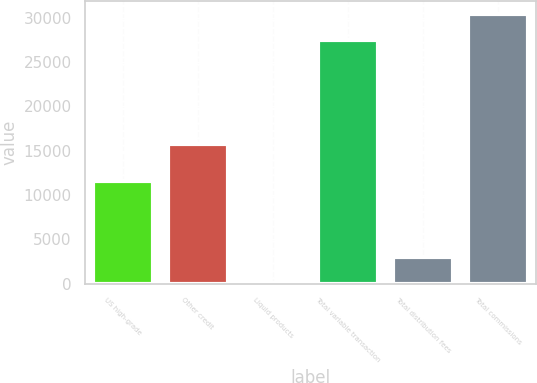<chart> <loc_0><loc_0><loc_500><loc_500><bar_chart><fcel>US high-grade<fcel>Other credit<fcel>Liquid products<fcel>Total variable transaction<fcel>Total distribution fees<fcel>Total commissions<nl><fcel>11545<fcel>15786<fcel>81<fcel>27412<fcel>3018.2<fcel>30349.2<nl></chart> 